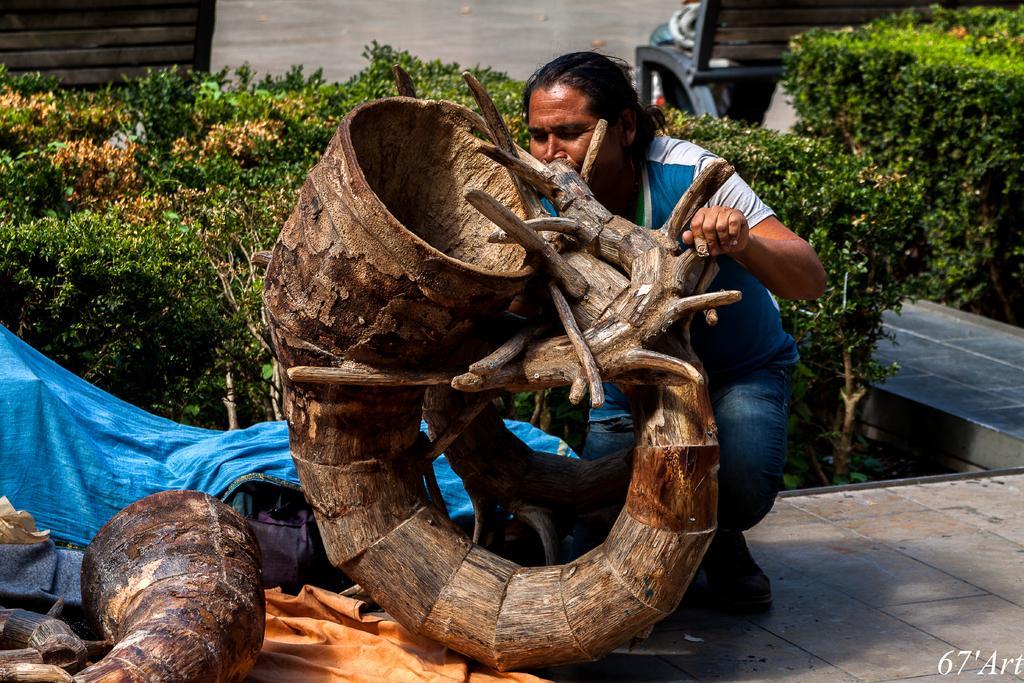In one or two sentences, can you explain what this image depicts? In this picture I can see brown color things in front and I can see a man who is holding a thing. In the middle of this picture I can see the blue color cloth. In the background I can see the bushes and brown color things on both the sides. I can see a watermark on the right bottom corner of this image. 